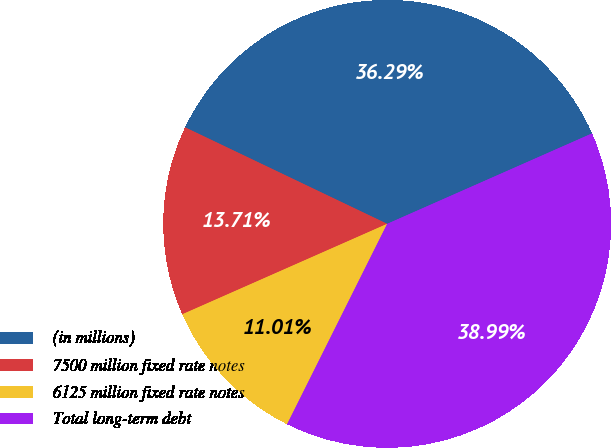Convert chart. <chart><loc_0><loc_0><loc_500><loc_500><pie_chart><fcel>(in millions)<fcel>7500 million fixed rate notes<fcel>6125 million fixed rate notes<fcel>Total long-term debt<nl><fcel>36.29%<fcel>13.71%<fcel>11.01%<fcel>38.99%<nl></chart> 